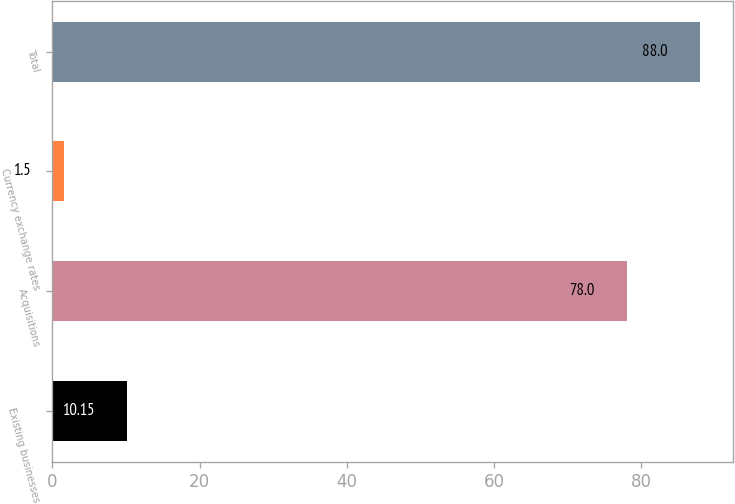Convert chart to OTSL. <chart><loc_0><loc_0><loc_500><loc_500><bar_chart><fcel>Existing businesses<fcel>Acquisitions<fcel>Currency exchange rates<fcel>Total<nl><fcel>10.15<fcel>78<fcel>1.5<fcel>88<nl></chart> 